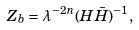<formula> <loc_0><loc_0><loc_500><loc_500>Z _ { b } = \lambda ^ { - 2 n } ( H \bar { H } ) ^ { - 1 } ,</formula> 